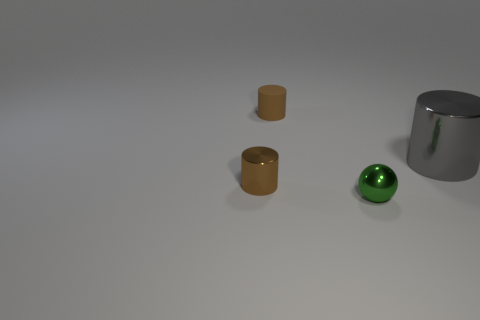Add 4 yellow cylinders. How many objects exist? 8 Subtract all cylinders. How many objects are left? 1 Add 4 tiny brown shiny cylinders. How many tiny brown shiny cylinders exist? 5 Subtract 0 blue blocks. How many objects are left? 4 Subtract all tiny green shiny spheres. Subtract all small balls. How many objects are left? 2 Add 2 metal balls. How many metal balls are left? 3 